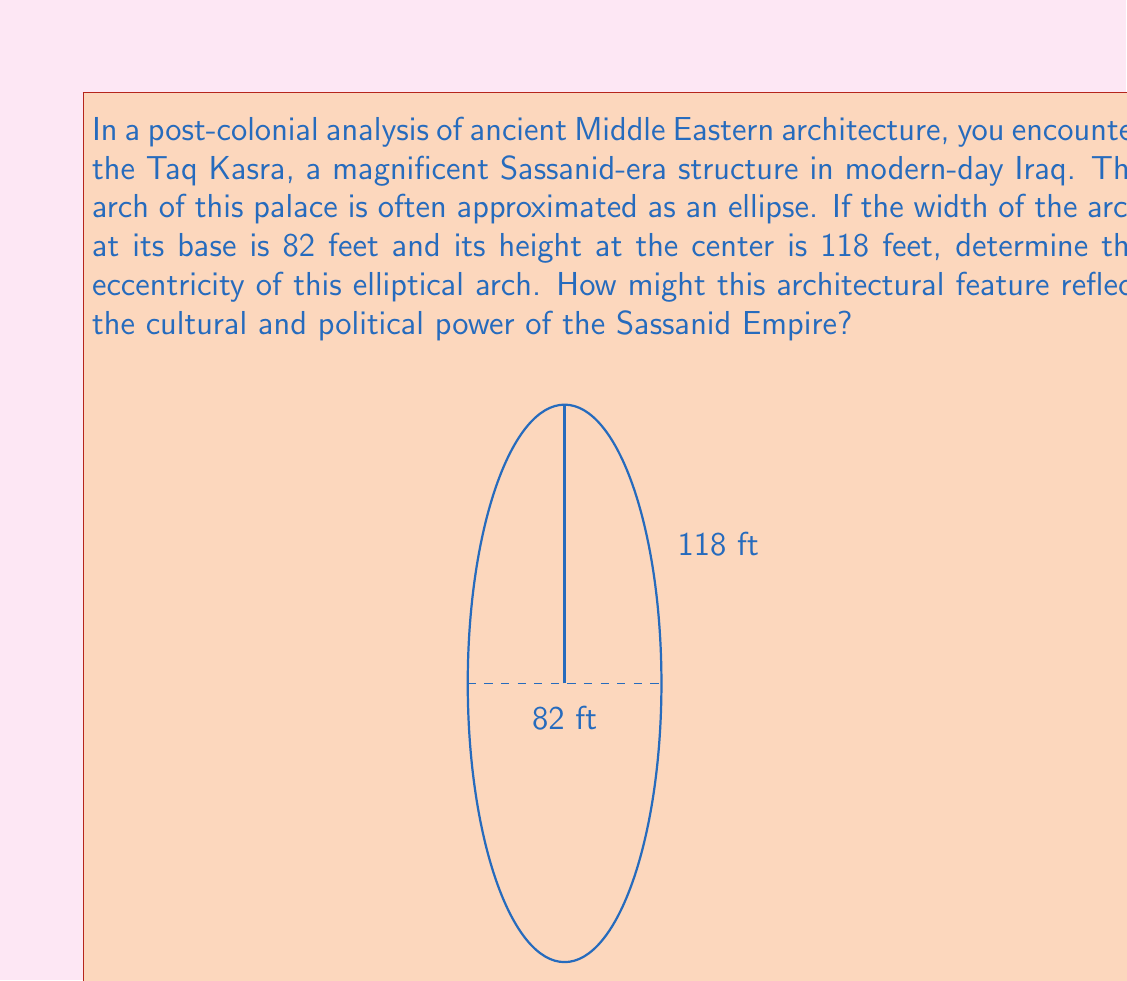What is the answer to this math problem? To analyze the elliptical arch of Taq Kasra, we'll follow these steps:

1) In an ellipse, the width is twice the length of the semi-major axis (a) and the height is twice the length of the semi-minor axis (b). Here:

   $a = 82/2 = 41$ feet (half-width)
   $b = 118$ feet (height)

2) The eccentricity (e) of an ellipse is given by the formula:

   $$e = \sqrt{1 - \frac{b^2}{a^2}}$$

3) Substituting our values:

   $$e = \sqrt{1 - \frac{118^2}{41^2}}$$

4) Simplifying:

   $$e = \sqrt{1 - \frac{13924}{1681}}$$
   $$e = \sqrt{1 - 8.2831}$$
   $$e = \sqrt{-7.2831}$$

5) Since we can't have a negative value under the square root, this tells us that our assumption about a and b was incorrect. In fact, 118 feet is the semi-major axis (a) and 41 feet is the semi-minor axis (b).

6) Recalculating with correct a and b:

   $$e = \sqrt{1 - \frac{41^2}{118^2}}$$
   $$e = \sqrt{1 - 0.1207}$$
   $$e = \sqrt{0.8793}$$
   $$e \approx 0.9376$$

This high eccentricity reflects the extreme elongation of the arch, symbolizing the vast reach and ambition of the Sassanid Empire. The imposing height of the arch (236 feet total) would have created a sense of awe in visitors, reinforcing the empire's power and grandeur.
Answer: $e \approx 0.9376$ 